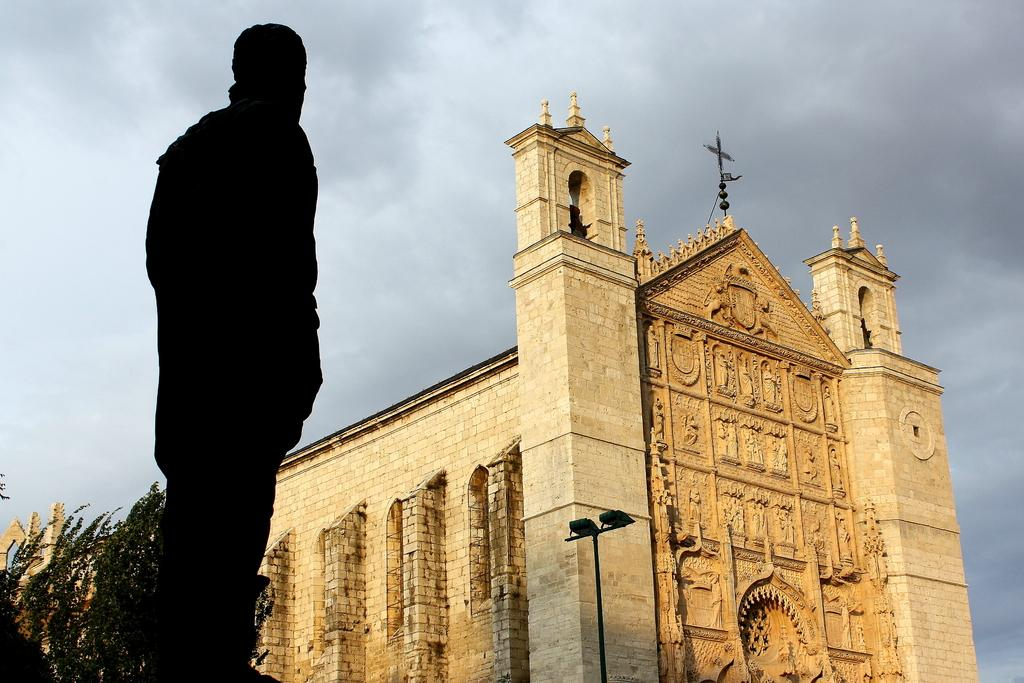What is the main subject in the image? There is a person standing in the image. What can be seen near the person? There is a pole in the image. What else is visible in the image? There are lights, trees, and a building in the image. What is visible in the background of the image? The sky is visible in the background of the image. What country is the person's brother from, as seen in the image? There is no information about a brother or a country in the image. 